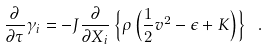<formula> <loc_0><loc_0><loc_500><loc_500>\frac { \partial } { \partial \tau } \gamma _ { i } = - J \frac { \partial } { \partial X _ { i } } \left \{ \rho \left ( \frac { 1 } { 2 } v ^ { 2 } - \epsilon + K \right ) \right \} \ .</formula> 